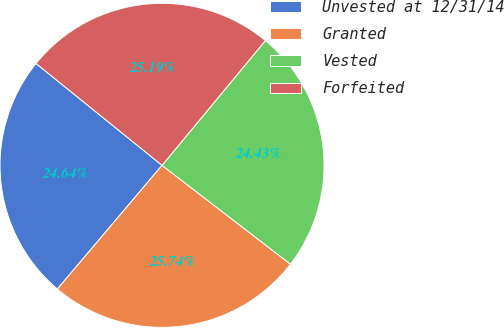Convert chart to OTSL. <chart><loc_0><loc_0><loc_500><loc_500><pie_chart><fcel>Unvested at 12/31/14<fcel>Granted<fcel>Vested<fcel>Forfeited<nl><fcel>24.64%<fcel>25.74%<fcel>24.43%<fcel>25.19%<nl></chart> 